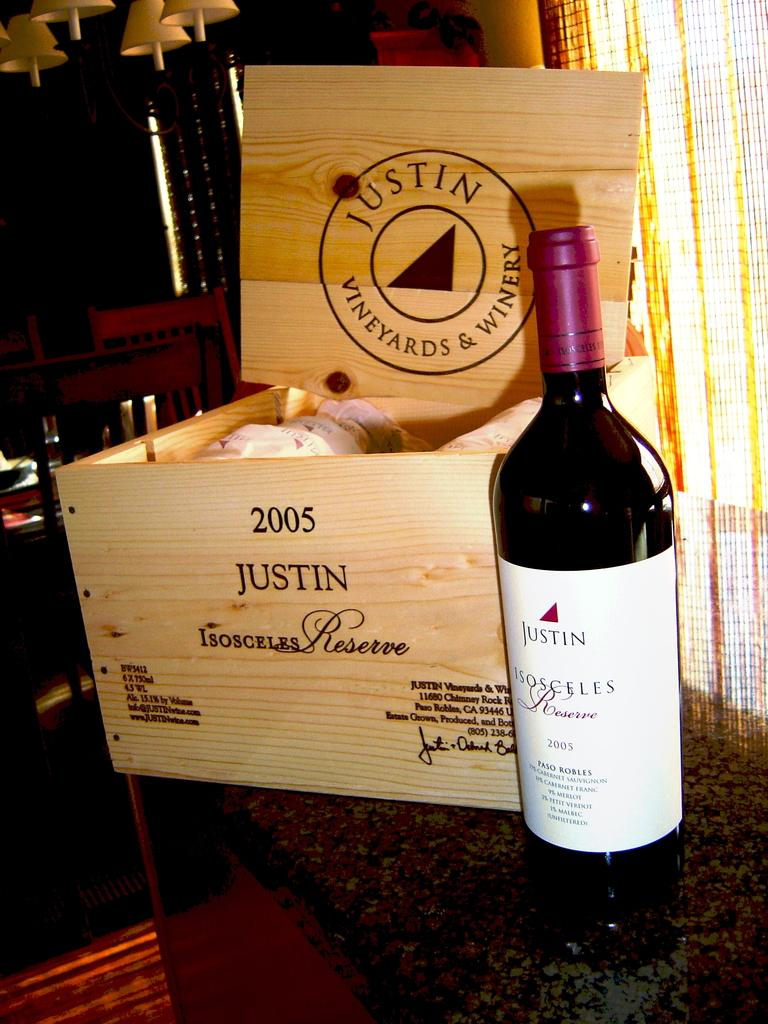<image>
Present a compact description of the photo's key features. A bottle of Justin Red wine stands unopened next to a classy wooden wine box. 